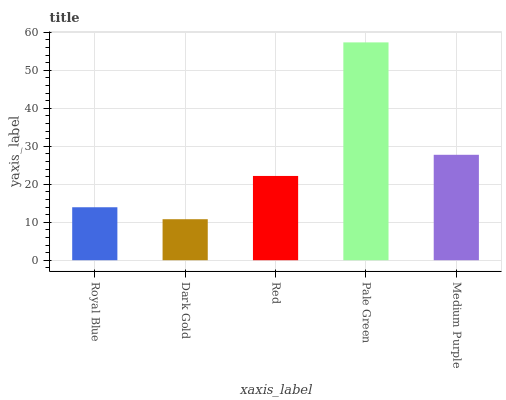Is Dark Gold the minimum?
Answer yes or no. Yes. Is Pale Green the maximum?
Answer yes or no. Yes. Is Red the minimum?
Answer yes or no. No. Is Red the maximum?
Answer yes or no. No. Is Red greater than Dark Gold?
Answer yes or no. Yes. Is Dark Gold less than Red?
Answer yes or no. Yes. Is Dark Gold greater than Red?
Answer yes or no. No. Is Red less than Dark Gold?
Answer yes or no. No. Is Red the high median?
Answer yes or no. Yes. Is Red the low median?
Answer yes or no. Yes. Is Medium Purple the high median?
Answer yes or no. No. Is Royal Blue the low median?
Answer yes or no. No. 